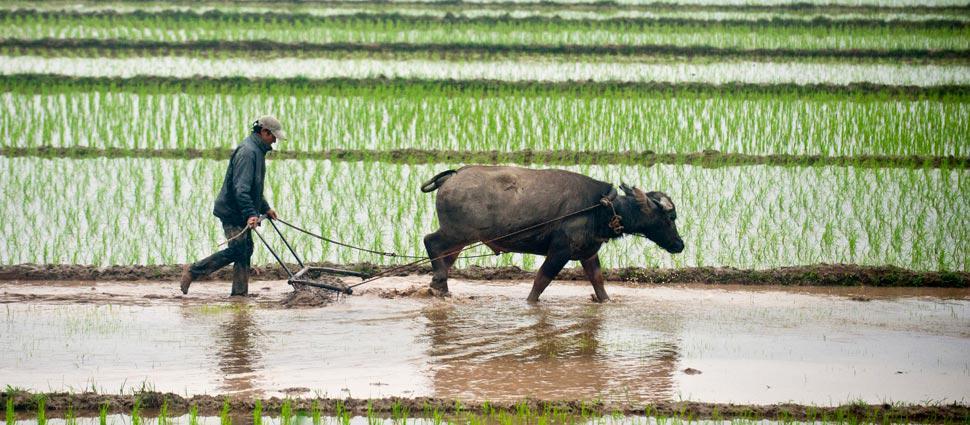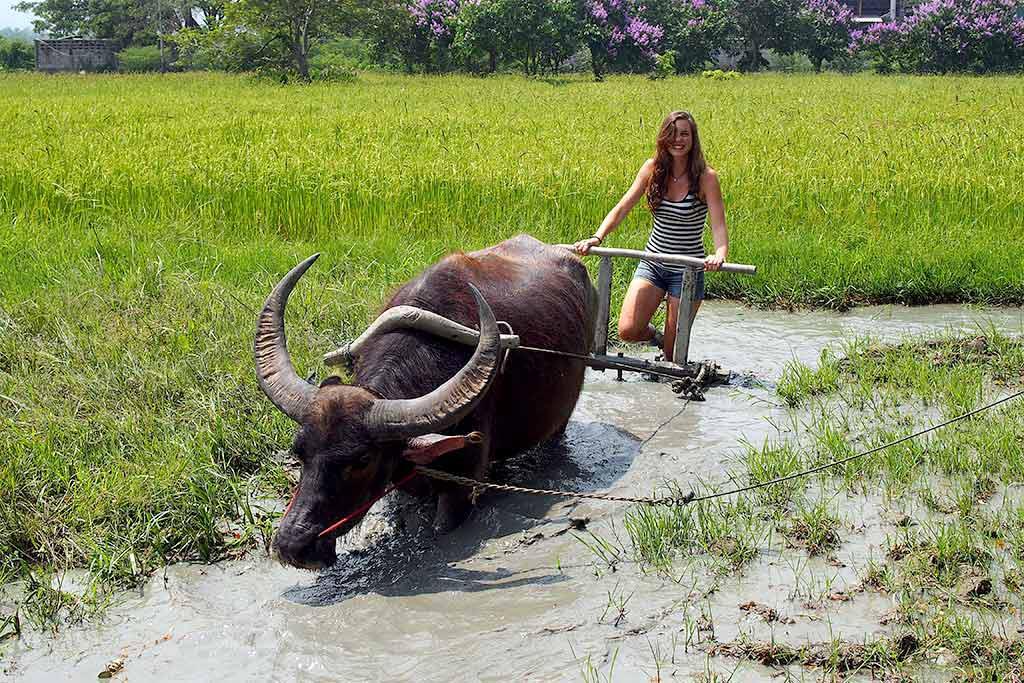The first image is the image on the left, the second image is the image on the right. Examine the images to the left and right. Is the description "The right image shows one woman walking leftward behind a plow pulled by one ox through a wet field, and the left image shows one man walking rightward behind a plow pulled by one ox through a wet field." accurate? Answer yes or no. Yes. The first image is the image on the left, the second image is the image on the right. For the images shown, is this caption "Each image shows a person walking behind an ox pulling a tiller" true? Answer yes or no. Yes. 